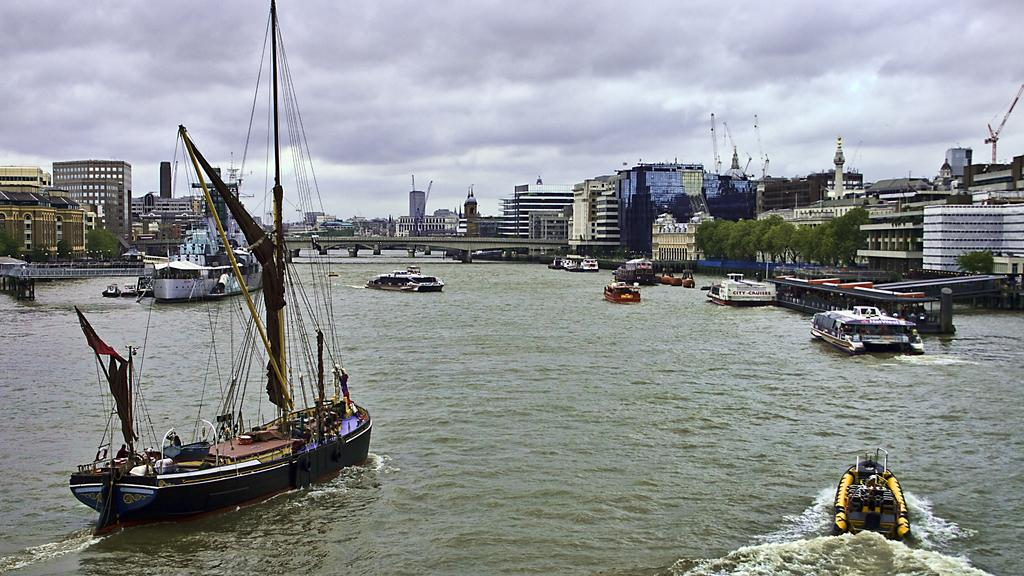What type of vehicles can be seen on the water in the image? There are boats on the water in the image. What structures can be seen in the background of the image? There are buildings, bridges, pillars, and trees in the background of the image. What type of construction equipment is visible in the background? There are cranes in the background of the image. How would you describe the sky in the image? The sky is cloudy in the image. Where is the sink located in the image? There is no sink present in the image. What type of town is depicted in the image? The image does not depict a town; it shows boats on the water and structures in the background. 